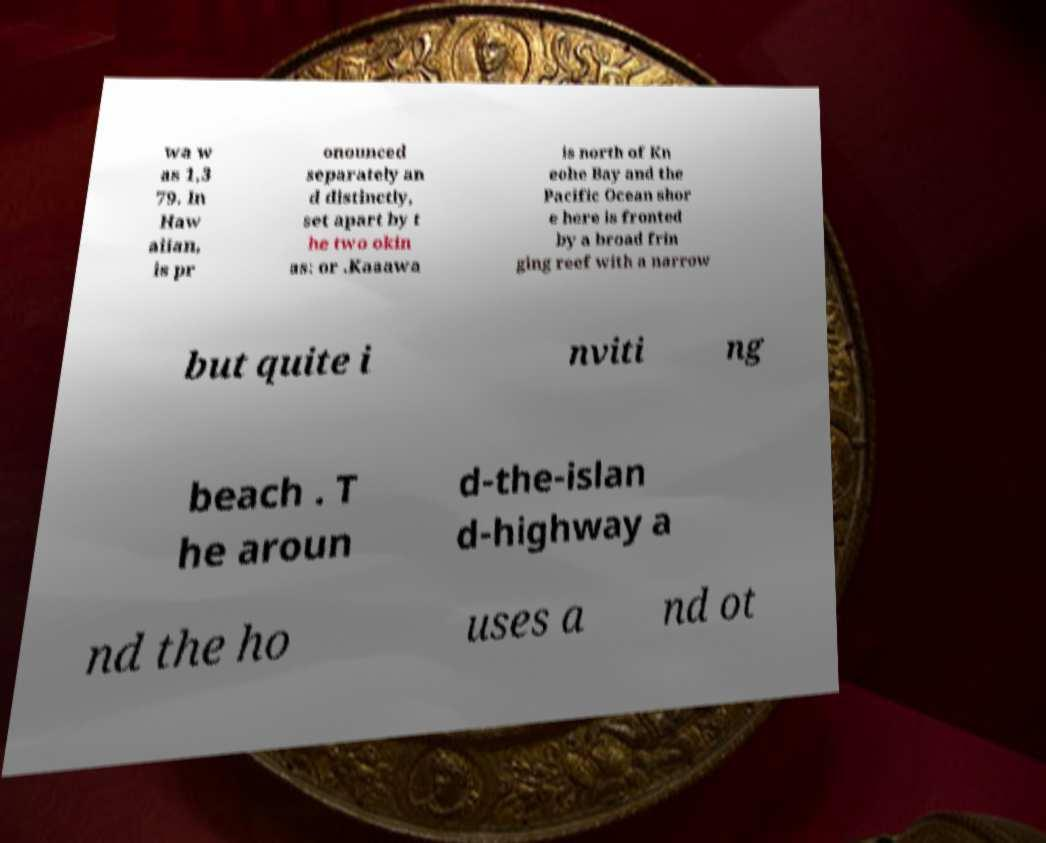What messages or text are displayed in this image? I need them in a readable, typed format. wa w as 1,3 79. In Haw aiian, is pr onounced separately an d distinctly, set apart by t he two okin as: or .Kaaawa is north of Kn eohe Bay and the Pacific Ocean shor e here is fronted by a broad frin ging reef with a narrow but quite i nviti ng beach . T he aroun d-the-islan d-highway a nd the ho uses a nd ot 